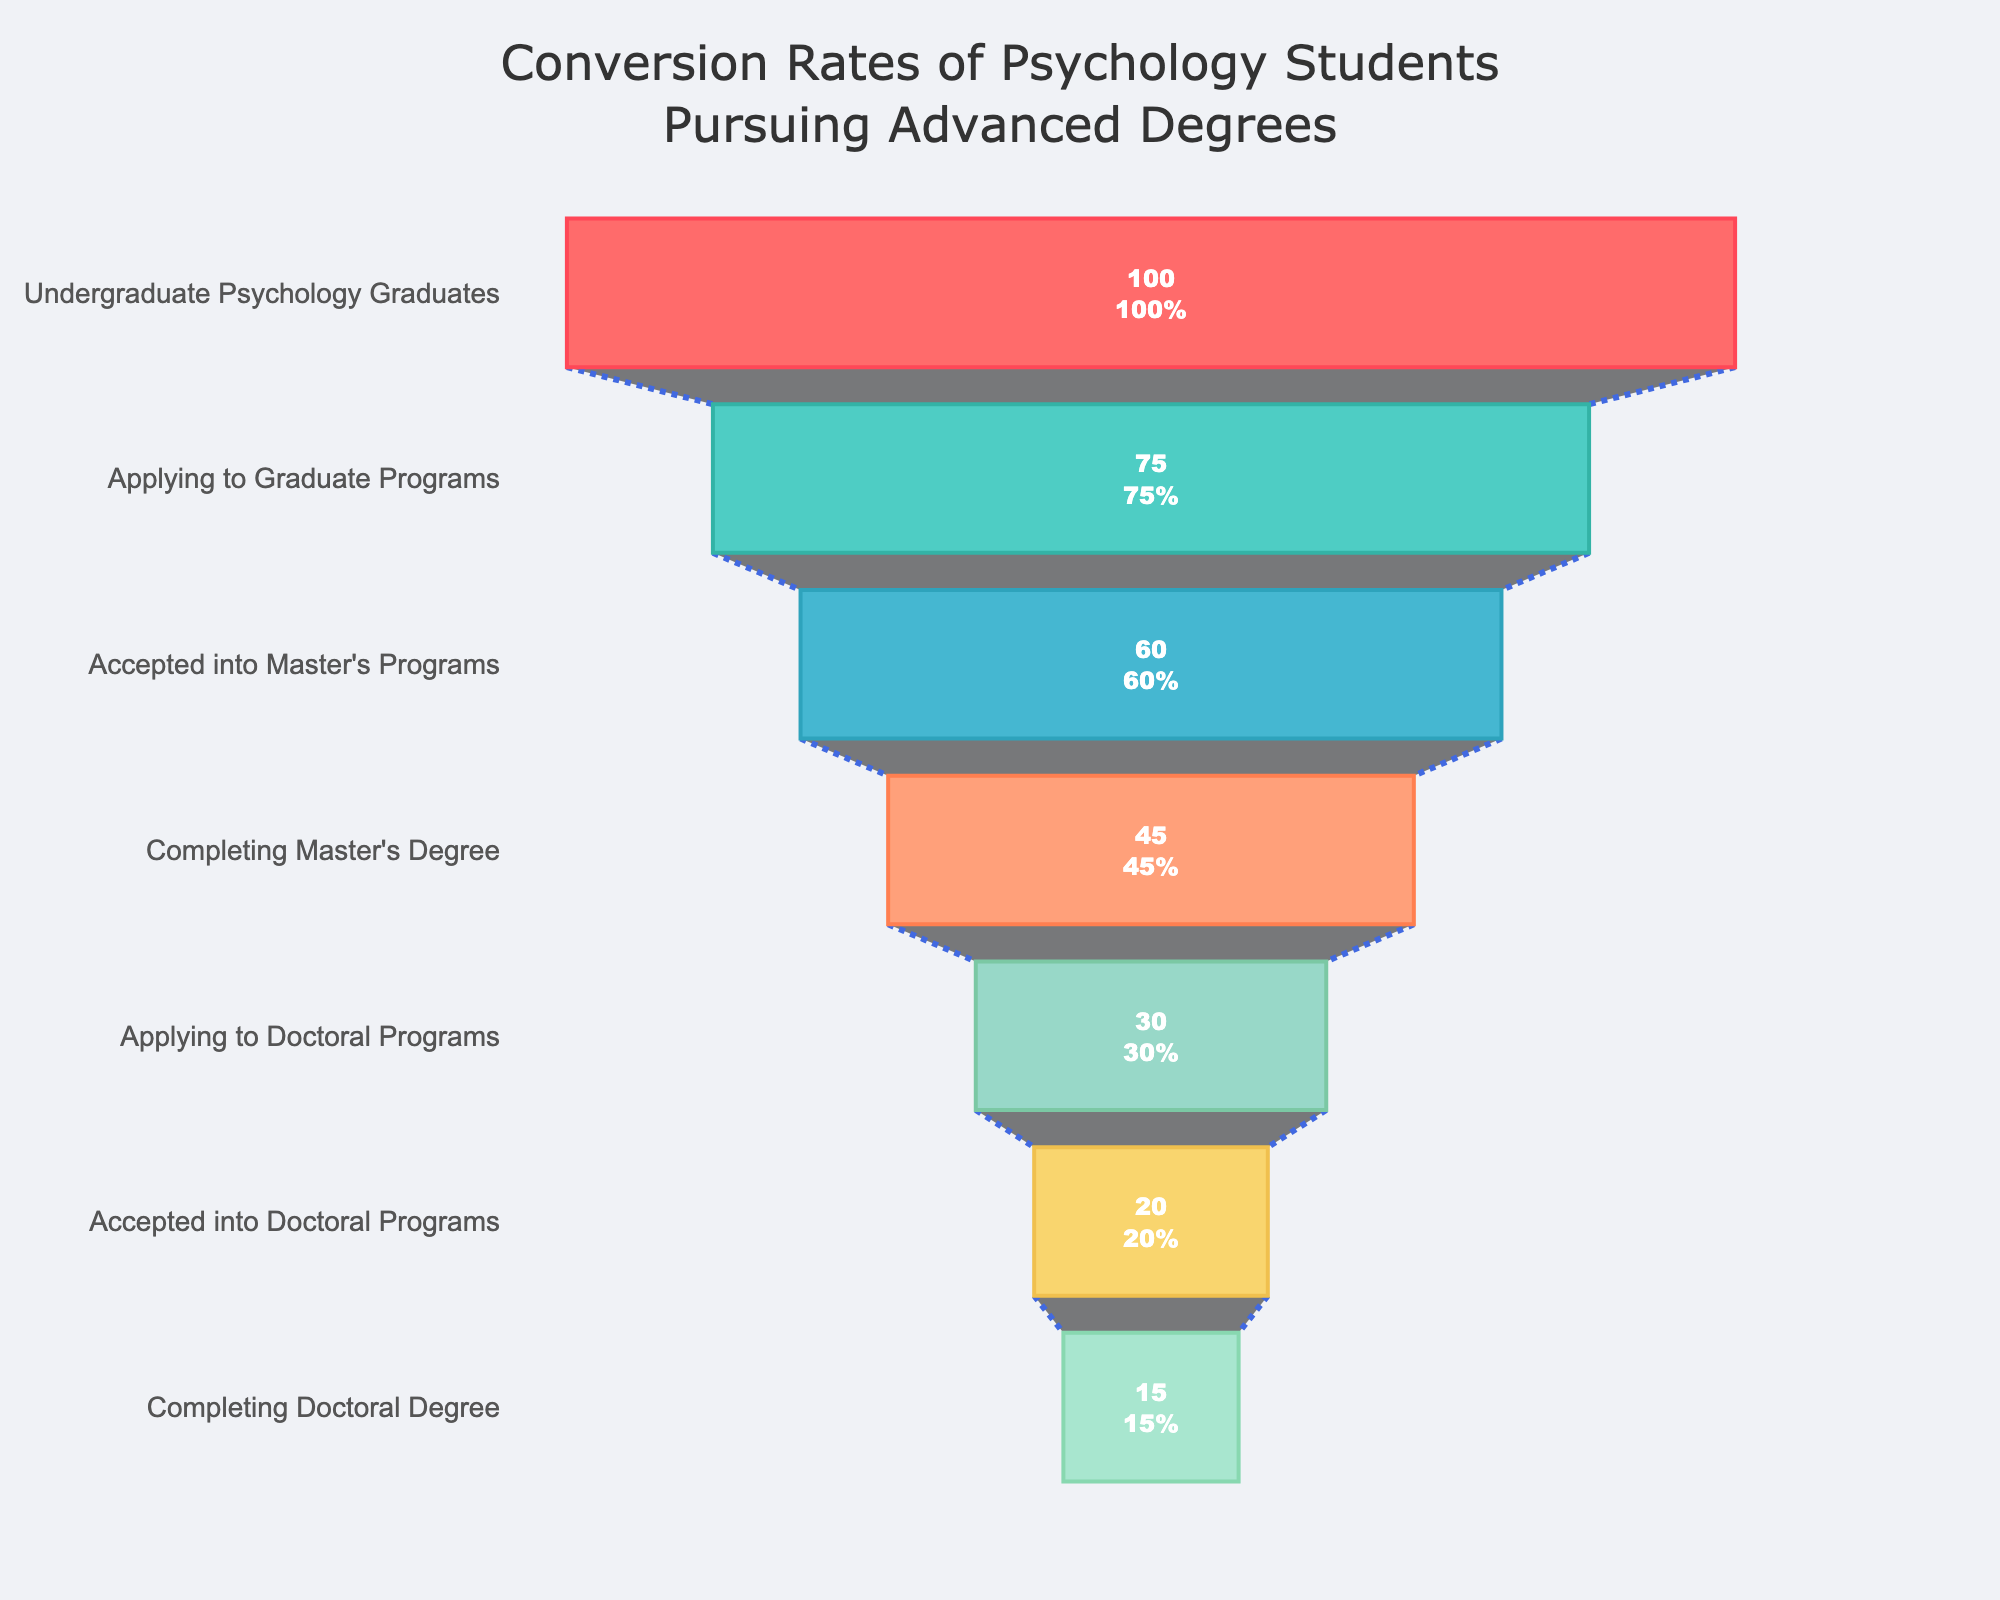What is the title of the funnel chart? The title is prominently displayed at the top of the chart. It reads, "Conversion Rates of Psychology Students Pursuing Advanced Degrees."
Answer: Conversion Rates of Psychology Students Pursuing Advanced Degrees How many stages are there in the funnel chart? By counting the number of unique stages listed on the y-axis, you can see there are seven distinct stages.
Answer: Seven What percentage of undergraduate psychology graduates apply to graduate programs? From the chart, the stage "Applying to Graduate Programs" directly shows a percentage of 75%.
Answer: 75% Which stage shows the largest drop in percentage from the previous stage? To determine this, calculate the percentage drop between each consecutive stage and identify the largest. From "Undergraduate Psychology Graduates" to "Applying to Graduate Programs" the drop is 100% - 75% = 25%. Other percentage drops are smaller.
Answer: Undergraduate Psychology Graduates to Applying to Graduate Programs What is the percentage of students who apply to doctoral programs after completing their master's degrees? According to the chart, the percentage of students at the stage "Applying to Doctoral Programs" is 30%.
Answer: 30% How many stages are specifically tied to students pursuing a doctoral degree? The stages relevant to a doctoral degree are "Applying to Doctoral Programs," "Accepted into Doctoral Programs," and "Completing Doctoral Degree." That's three stages.
Answer: Three Compare the percentage of students accepted into master's programs with those accepted into doctoral programs. Is there a higher acceptance rate for master's or doctoral programs? The chart shows 60% of students are accepted into master's programs, while 20% are accepted into doctoral programs. Thus, the acceptance rate for master's programs is higher.
Answer: Master’s Programs What is the final stage listed in the chart, and what percentage of students reach this stage? The final stage listed is "Completing Doctoral Degree," and the chart shows that 15% of students reach this stage.
Answer: Completing Doctoral Degree, 15% By what percentage does the student number decrease from those accepted into master's programs to those accepted into doctoral programs? First identify the percentages: 60% accepted into master's programs and 20% accepted into doctoral programs. The decrease is 60% - 20% = 40%.
Answer: 40% Given the stages and their percentages, what is the approximate percentage decrease from undergraduate psychology graduates to completing doctoral degrees? The chart shows 100% reach undergraduate psychology graduates and drops to 15% for completing doctoral degrees. This is a 100% - 15% = 85% total decrease.
Answer: 85% 